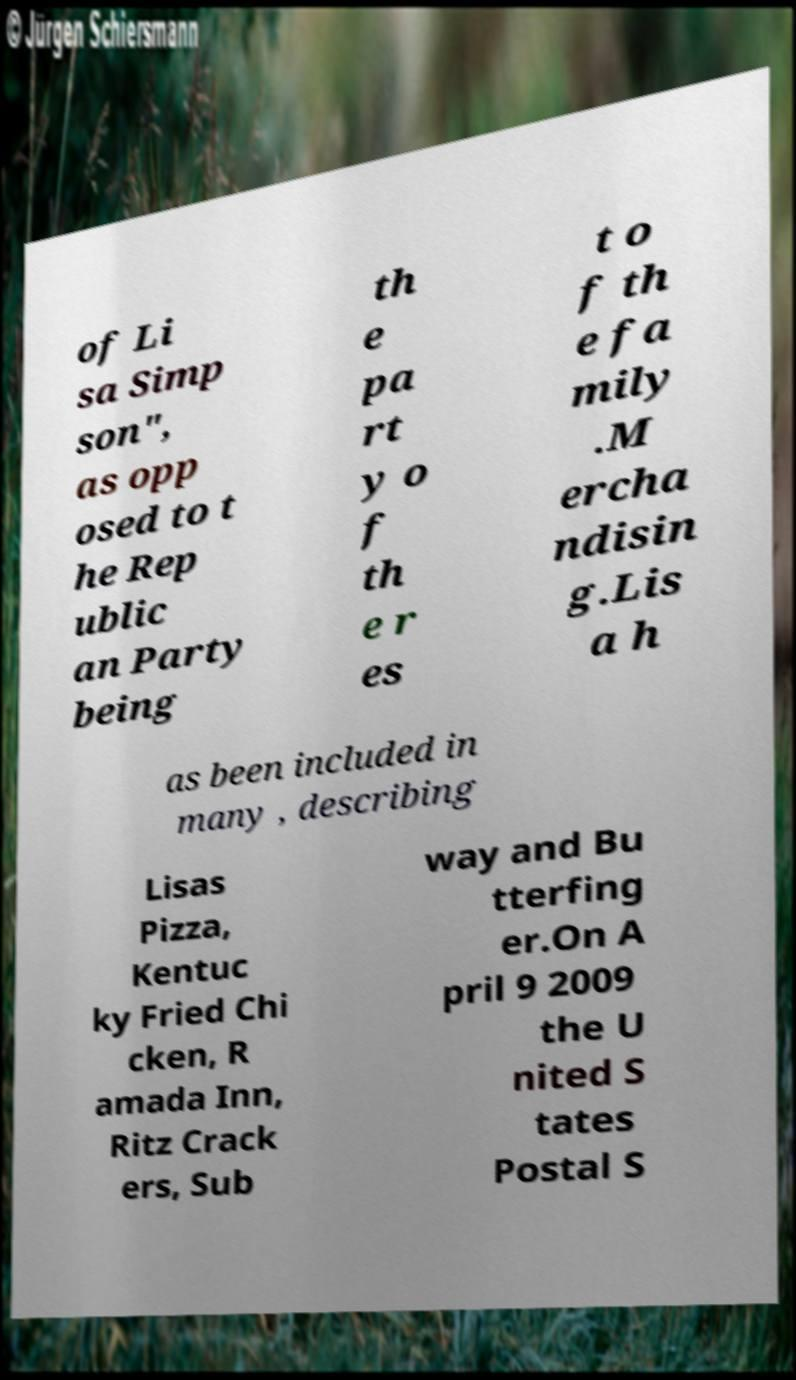For documentation purposes, I need the text within this image transcribed. Could you provide that? of Li sa Simp son", as opp osed to t he Rep ublic an Party being th e pa rt y o f th e r es t o f th e fa mily .M ercha ndisin g.Lis a h as been included in many , describing Lisas Pizza, Kentuc ky Fried Chi cken, R amada Inn, Ritz Crack ers, Sub way and Bu tterfing er.On A pril 9 2009 the U nited S tates Postal S 